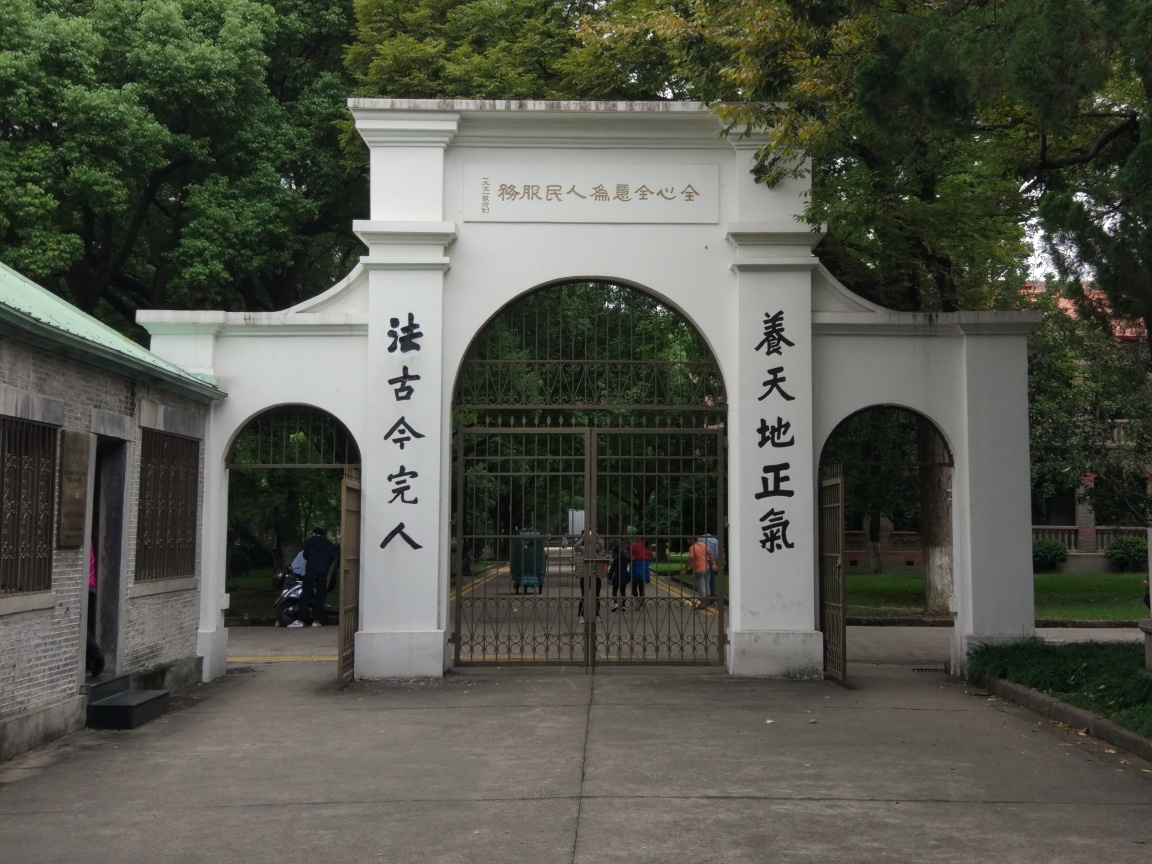Is the image distorted or warped? The image appears to be an unaltered photograph capturing the entrance of a location with Chinese calligraphy on it, suggesting a setting that may hold cultural or historical significance. There are no visible signs of distortion or warping; the gate structure, surrounding trees, and people in the background all look proportional and realistic. It's clear that the integrity of the image has been maintained, reflecting a true representation of the scene. 